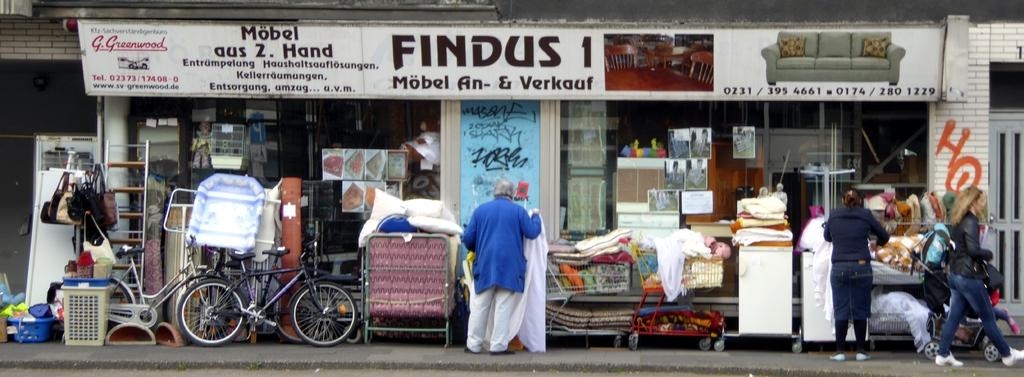<image>
Describe the image concisely. A storefront has a sign with the name Findus 1 on it. 